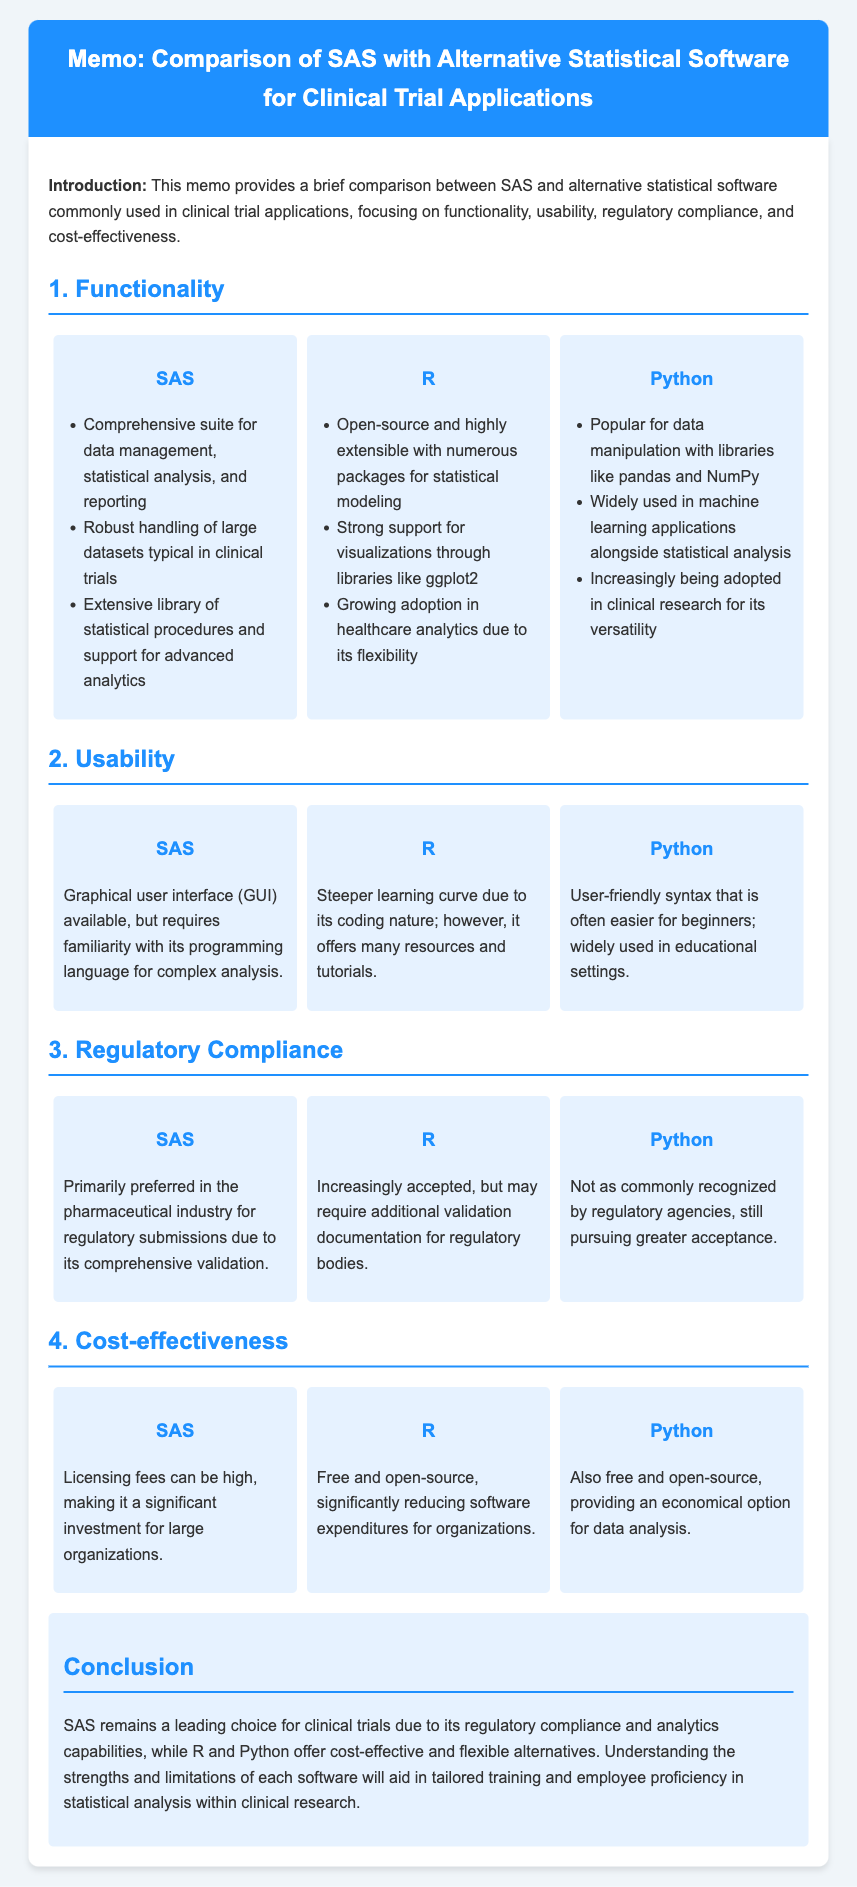What is the main topic of the memo? The main topic of the memo is a comparison between SAS and alternative statistical software for clinical trial applications.
Answer: Comparison of SAS with Alternative Statistical Software for Clinical Trial Applications Which software is primarily preferred in the pharmaceutical industry for regulatory submissions? The memo states that SAS is primarily preferred in the pharmaceutical industry for regulatory submissions.
Answer: SAS What is R's biggest advantage mentioned in functionality? R is noted for being open-source and highly extensible with numerous packages for statistical modeling.
Answer: Open-source and highly extensible with numerous packages for statistical modeling Which statistical software has the largest licensing fees? The document mentions that SAS has high licensing fees, making it a significant investment for organizations.
Answer: SAS What factor contributes to Python's increasing adoption in clinical research? Python's increasing adoption in clinical research is attributed to its versatility.
Answer: Versatility What learning curve is associated with R according to usability? The memo indicates that R has a steeper learning curve due to its coding nature.
Answer: Steeper learning curve Which software is free and open-source, reducing software expenditures? The document identifies both R and Python as free and open-source, which reduces software expenditures.
Answer: R and Python What conclusion is drawn regarding SAS in the context of clinical trials? The conclusion emphasizes SAS's leading role in clinical trials due to regulatory compliance and analytics capabilities.
Answer: SAS remains a leading choice for clinical trials How does SAS compare to R and Python in terms of cost-effectiveness? SAS is noted for having licensing fees, whereas R and Python are mentioned as free and open-source options.
Answer: SAS has high licensing fees; R and Python are free and open-source 